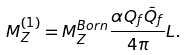Convert formula to latex. <formula><loc_0><loc_0><loc_500><loc_500>M _ { Z } ^ { ( 1 ) } = M _ { Z } ^ { B o r n } \frac { \alpha Q _ { f } \bar { Q } _ { f } } { 4 \pi } L .</formula> 